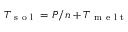Convert formula to latex. <formula><loc_0><loc_0><loc_500><loc_500>T _ { s o l } = P / n + T _ { m e l t }</formula> 